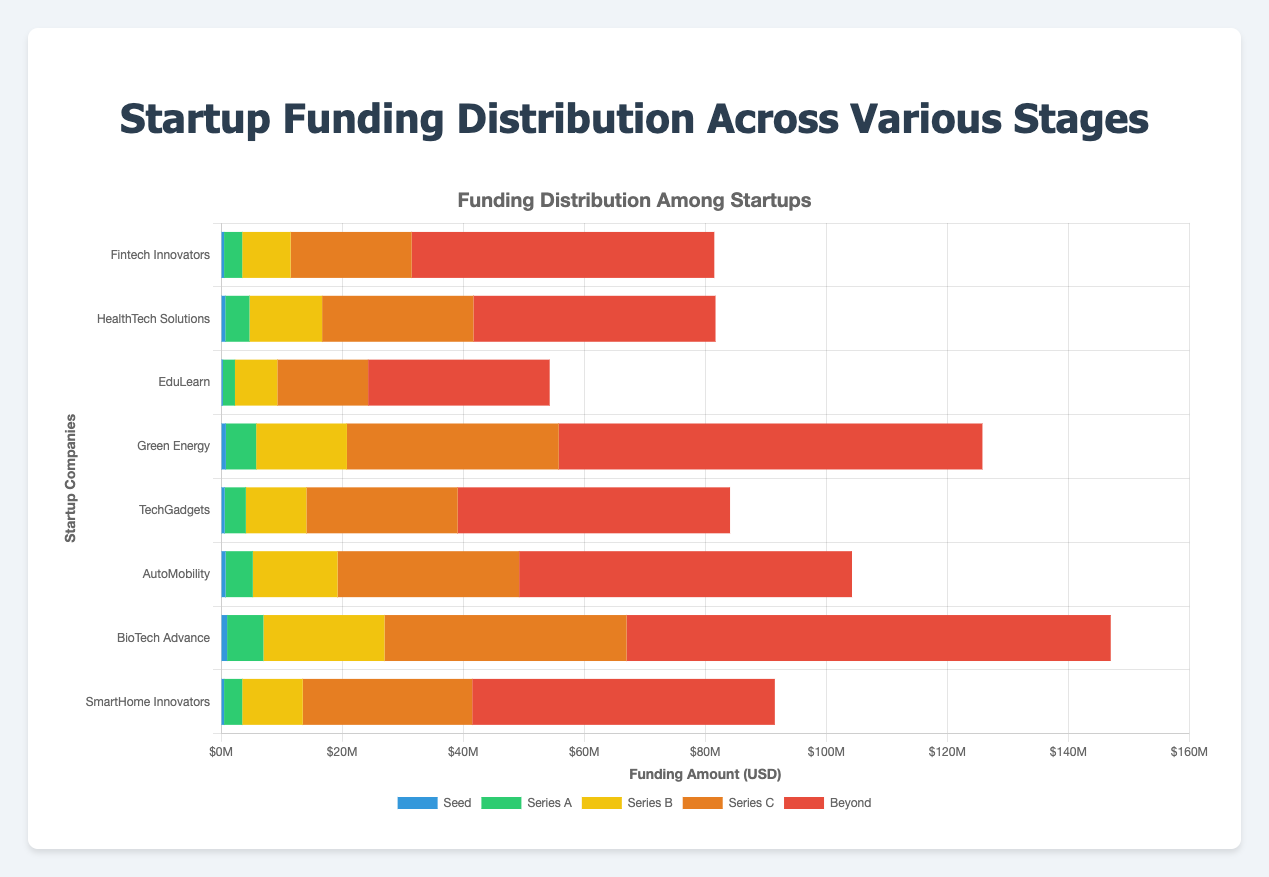What is the total funding amount for "BioTech Advance"? To find the total funding amount for "BioTech Advance", sum the funding across all stages: 1000000 (Seed) + 6000000 (Series A) + 20000000 (Series B) + 40000000 (Series C) + 80000000 (Beyond) = 147000000
Answer: 147 million USD Which startup has received the most funding in the "Seed" stage? Compare the "Seed" funding amounts for all startups. "BioTech Advance" has the highest with 1000000 USD
Answer: BioTech Advance How does the total funding of "Green Energy" compare to "AutoMobility"? Calculate the total funding for both startups and compare. "Green Energy": 800000 (Seed) + 5000000 (Series A) + 15000000 (Series B) + 35000000 (Series C) + 70000000 (Beyond) = 125800000; "AutoMobility": 750000 (Seed) + 4500000 (Series A) + 14000000 (Series B) + 30000000 (Series C) + 55000000 (Beyond) = 104500000
Answer: Green Energy has more total funding What is the average Series A funding for all startups? Sum the Series A funding for all startups and divide by the total number of startups. (3000000 + 4000000 + 2000000 + 5000000 + 3500000 + 4500000 + 6000000 + 3000000) / 8 = 31000000 / 8 = 3875000
Answer: 3.875 million USD Which startup has the smallest difference between "Seed" and "Beyond" funding stages? Calculate the difference between "Seed" and "Beyond" funding for each startup and find the smallest. "Fintech Innovators": 50000000 - 500000 = 49500000; "HealthTech Solutions": 40000000 - 700000 = 39300000; "EduLearn": 30000000 - 300000 = 29700000; "Green Energy": 70000000 - 800000 = 69200000; "TechGadgets": 45000000 - 600000 = 44400000; "AutoMobility": 55000000 - 750000 = 54250000; "BioTech Advance": 80000000 - 1000000 = 79000000; "SmartHome Innovators": 50000000 - 500000 = 49500000
Answer: EduLearn What is the combined Series C funding for "Fintech Innovators" and "HealthTech Solutions"? Add the Series C funding amounts for both startups: 20000000 (Fintech Innovators) + 25000000 (HealthTech Solutions) = 45000000
Answer: 45 million USD Which startup has the longest bar in the "Beyond" funding stage, and what color represents it? "BioTech Advance" has the highest "Beyond" funding of 80000000, and it is represented by the color red
Answer: BioTech Advance, red What percentage of total funding for "SmartHome Innovators" comes from the "Series B" stage? Calculate the Series B funding as a percentage of total funding. Total funding: 500000 (Seed) + 3000000 (Series A) + 10000000 (Series B) + 28000000 (Series C) + 50000000 (Beyond) = 91500000; Series B funding = 10000000; Percentage: (10000000 / 91500000) * 100 ≈ 10.93%
Answer: 10.93% How does the Series C funding in "TechGadgets" compare to "AutoMobility"? Compare the Series C funding amounts: "TechGadgets" has 25000000 and "AutoMobility" has 30000000
Answer: AutoMobility has more Series C funding 